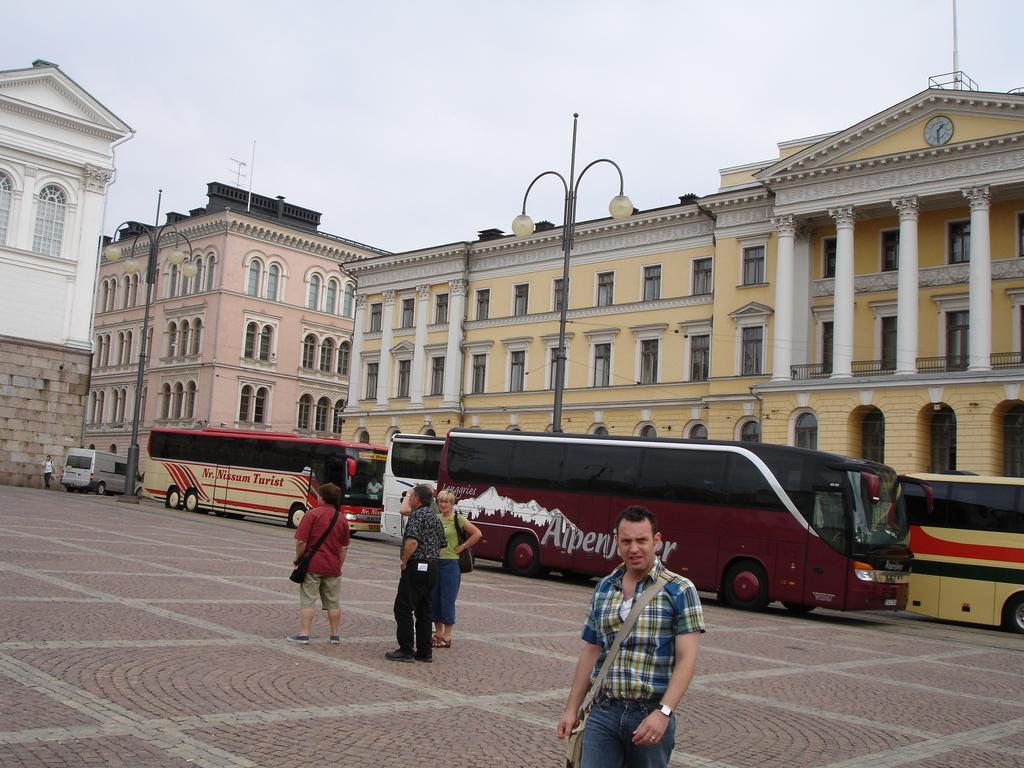In one or two sentences, can you explain what this image depicts? In the center of the image, we can see some buses and people on the road and in the background, there are lights, buildings. At the top, there is sky. 